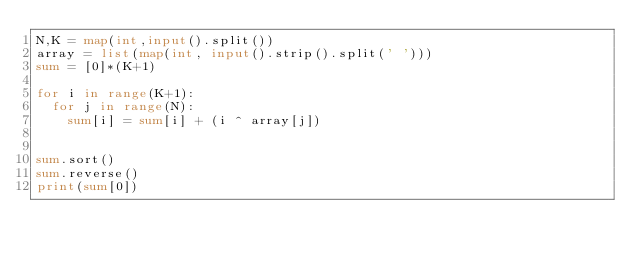Convert code to text. <code><loc_0><loc_0><loc_500><loc_500><_Python_>N,K = map(int,input().split())
array = list(map(int, input().strip().split(' ')))
sum = [0]*(K+1)

for i in range(K+1):
  for j in range(N):
    sum[i] = sum[i] + (i ^ array[j])

    
sum.sort()
sum.reverse()
print(sum[0])</code> 